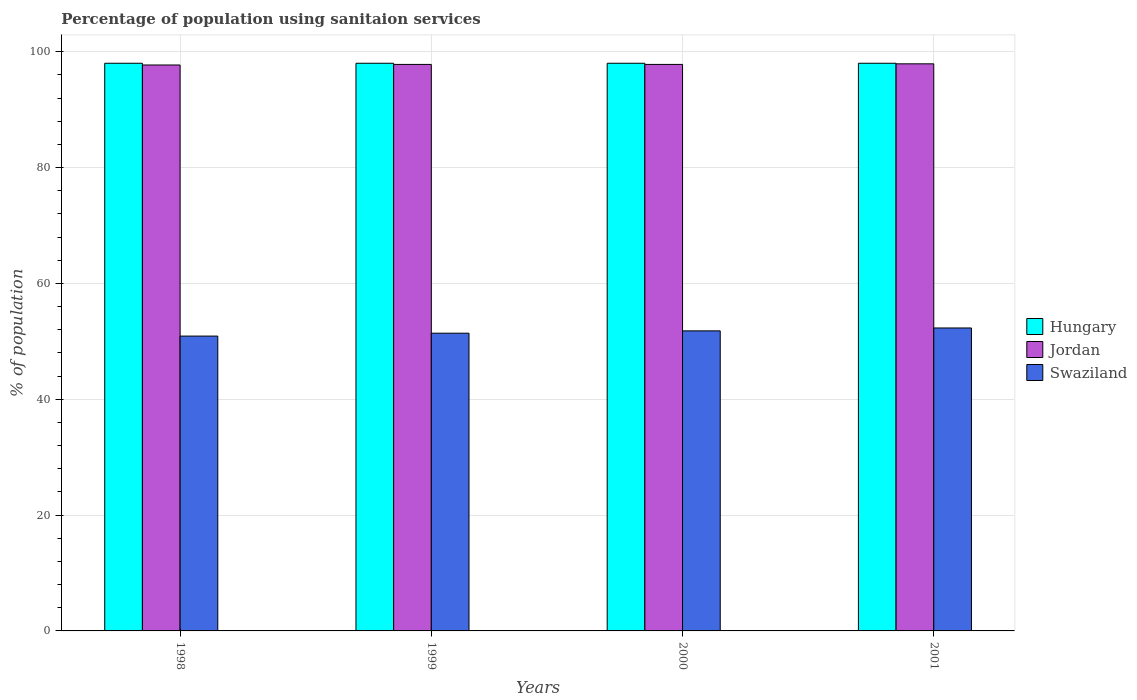How many different coloured bars are there?
Offer a terse response. 3. How many bars are there on the 3rd tick from the right?
Give a very brief answer. 3. What is the label of the 4th group of bars from the left?
Your answer should be compact. 2001. What is the percentage of population using sanitaion services in Jordan in 2001?
Your response must be concise. 97.9. Across all years, what is the maximum percentage of population using sanitaion services in Jordan?
Offer a terse response. 97.9. Across all years, what is the minimum percentage of population using sanitaion services in Swaziland?
Your answer should be very brief. 50.9. In which year was the percentage of population using sanitaion services in Hungary maximum?
Your answer should be compact. 1998. In which year was the percentage of population using sanitaion services in Hungary minimum?
Offer a terse response. 1998. What is the total percentage of population using sanitaion services in Jordan in the graph?
Your response must be concise. 391.2. What is the difference between the percentage of population using sanitaion services in Jordan in 1998 and that in 1999?
Your answer should be very brief. -0.1. What is the difference between the percentage of population using sanitaion services in Jordan in 2000 and the percentage of population using sanitaion services in Hungary in 1999?
Keep it short and to the point. -0.2. In the year 1998, what is the difference between the percentage of population using sanitaion services in Jordan and percentage of population using sanitaion services in Hungary?
Offer a very short reply. -0.3. What is the ratio of the percentage of population using sanitaion services in Swaziland in 1999 to that in 2000?
Offer a terse response. 0.99. What is the difference between the highest and the second highest percentage of population using sanitaion services in Hungary?
Provide a short and direct response. 0. What is the difference between the highest and the lowest percentage of population using sanitaion services in Hungary?
Offer a terse response. 0. In how many years, is the percentage of population using sanitaion services in Swaziland greater than the average percentage of population using sanitaion services in Swaziland taken over all years?
Offer a terse response. 2. What does the 2nd bar from the left in 1999 represents?
Your answer should be very brief. Jordan. What does the 1st bar from the right in 1998 represents?
Keep it short and to the point. Swaziland. How many bars are there?
Your answer should be very brief. 12. How many years are there in the graph?
Provide a succinct answer. 4. Does the graph contain grids?
Your answer should be very brief. Yes. Where does the legend appear in the graph?
Your answer should be very brief. Center right. How are the legend labels stacked?
Provide a short and direct response. Vertical. What is the title of the graph?
Give a very brief answer. Percentage of population using sanitaion services. What is the label or title of the Y-axis?
Give a very brief answer. % of population. What is the % of population in Hungary in 1998?
Your answer should be compact. 98. What is the % of population in Jordan in 1998?
Provide a short and direct response. 97.7. What is the % of population in Swaziland in 1998?
Give a very brief answer. 50.9. What is the % of population in Hungary in 1999?
Provide a succinct answer. 98. What is the % of population of Jordan in 1999?
Ensure brevity in your answer.  97.8. What is the % of population in Swaziland in 1999?
Give a very brief answer. 51.4. What is the % of population in Jordan in 2000?
Keep it short and to the point. 97.8. What is the % of population of Swaziland in 2000?
Offer a terse response. 51.8. What is the % of population of Jordan in 2001?
Ensure brevity in your answer.  97.9. What is the % of population in Swaziland in 2001?
Your response must be concise. 52.3. Across all years, what is the maximum % of population in Jordan?
Ensure brevity in your answer.  97.9. Across all years, what is the maximum % of population in Swaziland?
Provide a short and direct response. 52.3. Across all years, what is the minimum % of population in Hungary?
Your response must be concise. 98. Across all years, what is the minimum % of population of Jordan?
Your answer should be compact. 97.7. Across all years, what is the minimum % of population of Swaziland?
Provide a succinct answer. 50.9. What is the total % of population in Hungary in the graph?
Your response must be concise. 392. What is the total % of population of Jordan in the graph?
Give a very brief answer. 391.2. What is the total % of population in Swaziland in the graph?
Ensure brevity in your answer.  206.4. What is the difference between the % of population in Jordan in 1998 and that in 1999?
Your response must be concise. -0.1. What is the difference between the % of population of Jordan in 1998 and that in 2000?
Give a very brief answer. -0.1. What is the difference between the % of population in Jordan in 1998 and that in 2001?
Your answer should be very brief. -0.2. What is the difference between the % of population in Swaziland in 1999 and that in 2000?
Your answer should be very brief. -0.4. What is the difference between the % of population in Hungary in 1999 and that in 2001?
Keep it short and to the point. 0. What is the difference between the % of population in Hungary in 2000 and that in 2001?
Ensure brevity in your answer.  0. What is the difference between the % of population in Swaziland in 2000 and that in 2001?
Ensure brevity in your answer.  -0.5. What is the difference between the % of population in Hungary in 1998 and the % of population in Jordan in 1999?
Offer a very short reply. 0.2. What is the difference between the % of population of Hungary in 1998 and the % of population of Swaziland in 1999?
Your answer should be very brief. 46.6. What is the difference between the % of population in Jordan in 1998 and the % of population in Swaziland in 1999?
Provide a succinct answer. 46.3. What is the difference between the % of population in Hungary in 1998 and the % of population in Swaziland in 2000?
Make the answer very short. 46.2. What is the difference between the % of population of Jordan in 1998 and the % of population of Swaziland in 2000?
Your answer should be very brief. 45.9. What is the difference between the % of population of Hungary in 1998 and the % of population of Jordan in 2001?
Provide a succinct answer. 0.1. What is the difference between the % of population in Hungary in 1998 and the % of population in Swaziland in 2001?
Make the answer very short. 45.7. What is the difference between the % of population of Jordan in 1998 and the % of population of Swaziland in 2001?
Provide a short and direct response. 45.4. What is the difference between the % of population in Hungary in 1999 and the % of population in Jordan in 2000?
Make the answer very short. 0.2. What is the difference between the % of population of Hungary in 1999 and the % of population of Swaziland in 2000?
Your response must be concise. 46.2. What is the difference between the % of population in Hungary in 1999 and the % of population in Jordan in 2001?
Offer a terse response. 0.1. What is the difference between the % of population in Hungary in 1999 and the % of population in Swaziland in 2001?
Give a very brief answer. 45.7. What is the difference between the % of population in Jordan in 1999 and the % of population in Swaziland in 2001?
Offer a terse response. 45.5. What is the difference between the % of population of Hungary in 2000 and the % of population of Jordan in 2001?
Offer a very short reply. 0.1. What is the difference between the % of population in Hungary in 2000 and the % of population in Swaziland in 2001?
Give a very brief answer. 45.7. What is the difference between the % of population of Jordan in 2000 and the % of population of Swaziland in 2001?
Provide a succinct answer. 45.5. What is the average % of population of Hungary per year?
Give a very brief answer. 98. What is the average % of population of Jordan per year?
Provide a succinct answer. 97.8. What is the average % of population of Swaziland per year?
Your response must be concise. 51.6. In the year 1998, what is the difference between the % of population in Hungary and % of population in Jordan?
Your answer should be very brief. 0.3. In the year 1998, what is the difference between the % of population in Hungary and % of population in Swaziland?
Give a very brief answer. 47.1. In the year 1998, what is the difference between the % of population in Jordan and % of population in Swaziland?
Your answer should be compact. 46.8. In the year 1999, what is the difference between the % of population in Hungary and % of population in Swaziland?
Give a very brief answer. 46.6. In the year 1999, what is the difference between the % of population in Jordan and % of population in Swaziland?
Your response must be concise. 46.4. In the year 2000, what is the difference between the % of population in Hungary and % of population in Swaziland?
Offer a very short reply. 46.2. In the year 2000, what is the difference between the % of population of Jordan and % of population of Swaziland?
Ensure brevity in your answer.  46. In the year 2001, what is the difference between the % of population of Hungary and % of population of Swaziland?
Your answer should be compact. 45.7. In the year 2001, what is the difference between the % of population of Jordan and % of population of Swaziland?
Give a very brief answer. 45.6. What is the ratio of the % of population in Jordan in 1998 to that in 1999?
Your response must be concise. 1. What is the ratio of the % of population in Swaziland in 1998 to that in 1999?
Offer a terse response. 0.99. What is the ratio of the % of population in Hungary in 1998 to that in 2000?
Your answer should be very brief. 1. What is the ratio of the % of population of Jordan in 1998 to that in 2000?
Keep it short and to the point. 1. What is the ratio of the % of population of Swaziland in 1998 to that in 2000?
Offer a terse response. 0.98. What is the ratio of the % of population in Swaziland in 1998 to that in 2001?
Ensure brevity in your answer.  0.97. What is the ratio of the % of population of Jordan in 1999 to that in 2000?
Provide a succinct answer. 1. What is the ratio of the % of population of Jordan in 1999 to that in 2001?
Your answer should be very brief. 1. What is the ratio of the % of population of Swaziland in 1999 to that in 2001?
Your response must be concise. 0.98. What is the ratio of the % of population in Swaziland in 2000 to that in 2001?
Your response must be concise. 0.99. What is the difference between the highest and the second highest % of population in Swaziland?
Offer a very short reply. 0.5. What is the difference between the highest and the lowest % of population of Swaziland?
Give a very brief answer. 1.4. 